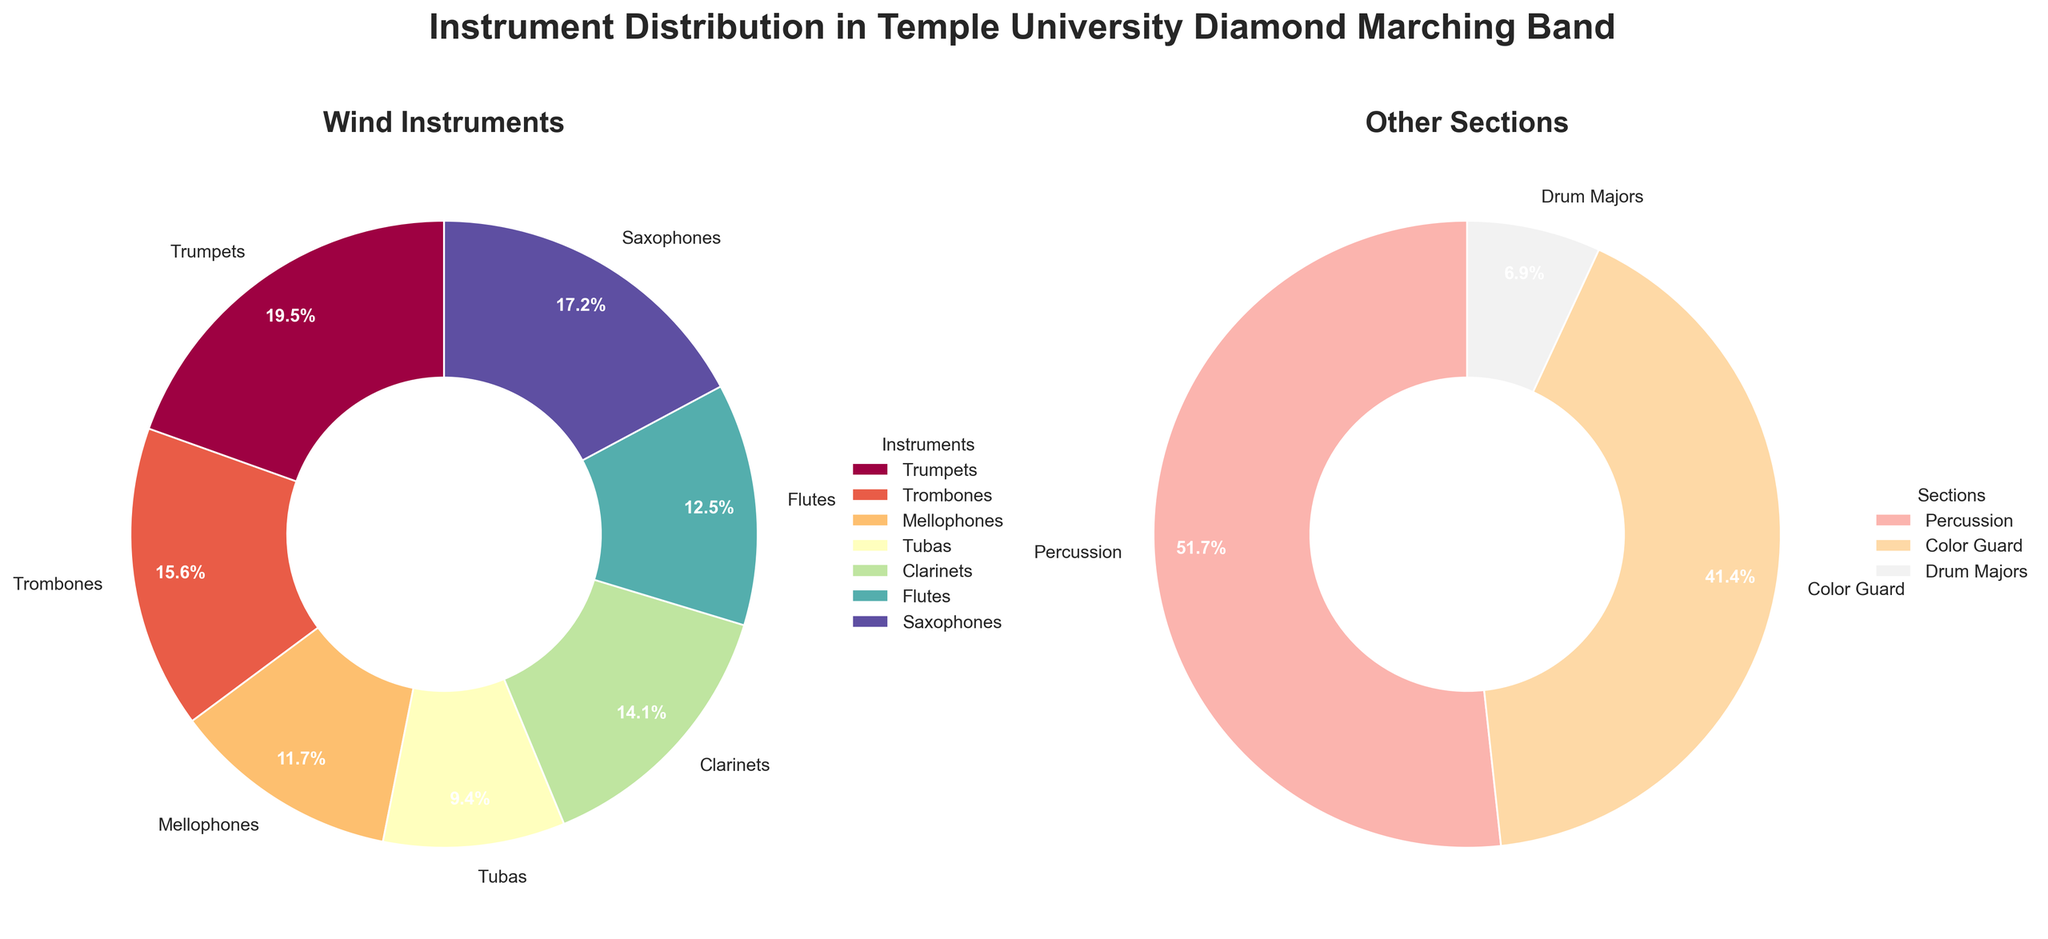How many more instruments are in the Percussion section compared to the Flutes section? The Percussion section has 30 instruments, and the Flutes section has 16 instruments. The difference is calculated as 30 - 16 = 14.
Answer: 14 Which wind instrument has the largest count, and what is it? By observing the wind instruments pie chart, the Trumpets section has the largest count.
Answer: Trumpets What percentage of the total wind instruments are Saxophones? The total counts for wind instruments are 25 (Trumpets) + 20 (Trombones) + 15 (Mellophones) + 12 (Tubas) + 18 (Clarinets) + 16 (Flutes) + 22 (Saxophones) = 128. The Saxophones make up (22 / 128) * 100 = 17.2%.
Answer: 17.2% Which section in the "Other Sections" pie chart occupies a smaller portion, Drum Majors or Color Guard? Drum Majors have 4, while Color Guard has 24. Drum Majors have a smaller count, hence a smaller portion.
Answer: Drum Majors How many more wind instruments are there compared to the "Other Sections"? Total wind instruments = 25 + 20 + 15 + 12 + 18 + 16 + 22 = 128. Total other sections = 30 + 24 + 4 = 58. Difference = 128 - 58 = 70.
Answer: 70 What is the combined percentage of Mellophones and Tubas among the wind instruments? Mellophones have a count of 15, and Tubas have 12. Combined count = 15 + 12 = 27. Total wind instruments count = 128. Percentage = (27 / 128) * 100 ≈ 21.1%.
Answer: 21.1% Is the Color Guard section larger or smaller than the Wind section with the smallest count? Color Guard has 24 instruments. Among the wind instruments, Tubas have the smallest count with 12. 24 is larger than 12.
Answer: Larger Which section has the smallest portion in the "Other Sections" pie chart? The Drum Majors section, with 4 instruments, has the smallest portion.
Answer: Drum Majors Out of the total band members, how many belong to Color Guard or Drum Majors? Color Guard has 24, Drum Majors have 4. Combined = 24 + 4 = 28.
Answer: 28 